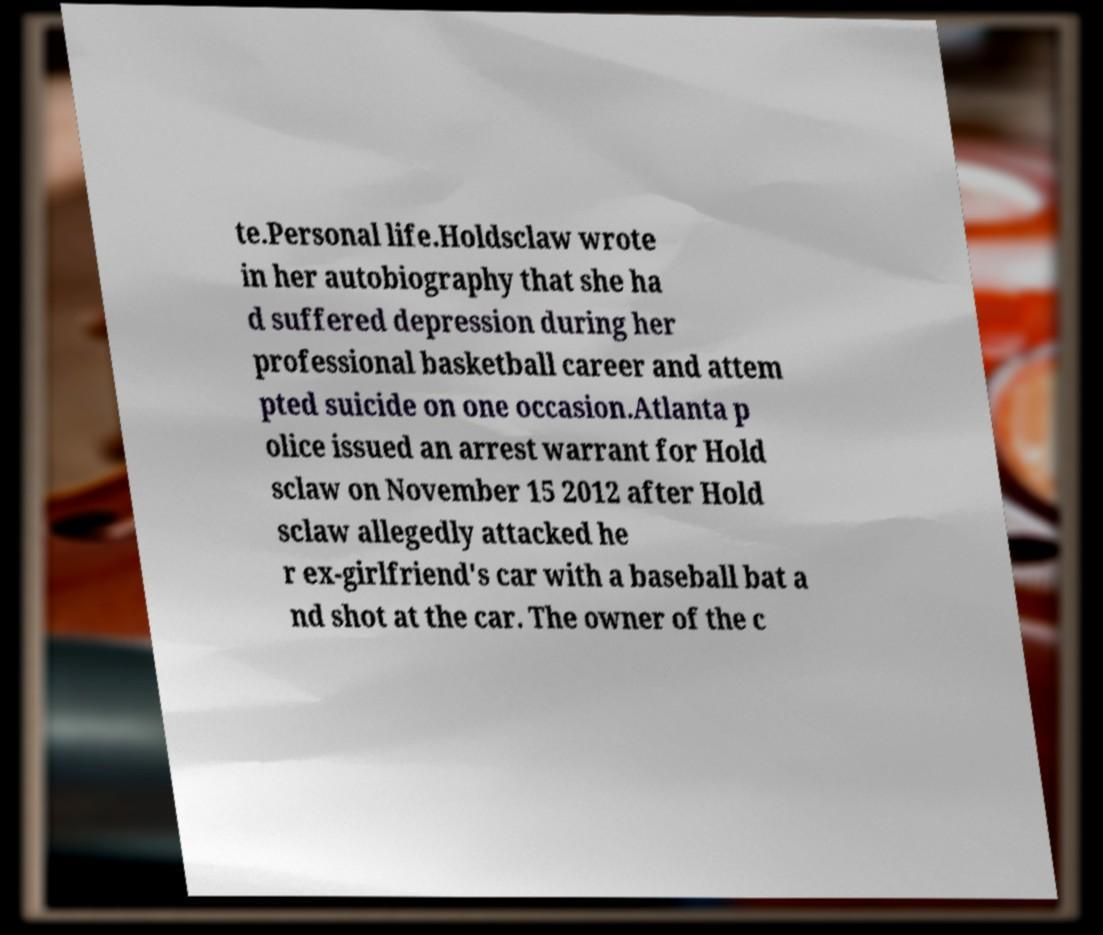Can you accurately transcribe the text from the provided image for me? te.Personal life.Holdsclaw wrote in her autobiography that she ha d suffered depression during her professional basketball career and attem pted suicide on one occasion.Atlanta p olice issued an arrest warrant for Hold sclaw on November 15 2012 after Hold sclaw allegedly attacked he r ex-girlfriend's car with a baseball bat a nd shot at the car. The owner of the c 